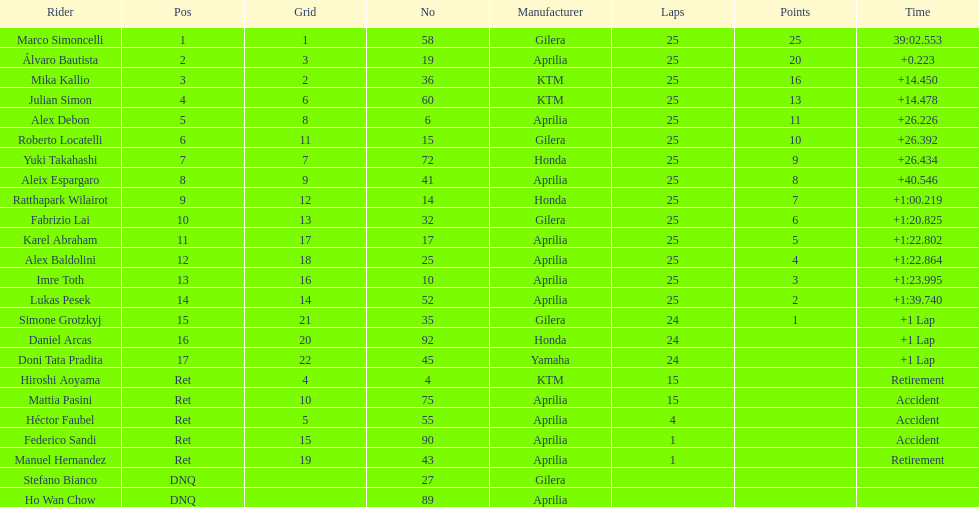Parse the table in full. {'header': ['Rider', 'Pos', 'Grid', 'No', 'Manufacturer', 'Laps', 'Points', 'Time'], 'rows': [['Marco Simoncelli', '1', '1', '58', 'Gilera', '25', '25', '39:02.553'], ['Álvaro Bautista', '2', '3', '19', 'Aprilia', '25', '20', '+0.223'], ['Mika Kallio', '3', '2', '36', 'KTM', '25', '16', '+14.450'], ['Julian Simon', '4', '6', '60', 'KTM', '25', '13', '+14.478'], ['Alex Debon', '5', '8', '6', 'Aprilia', '25', '11', '+26.226'], ['Roberto Locatelli', '6', '11', '15', 'Gilera', '25', '10', '+26.392'], ['Yuki Takahashi', '7', '7', '72', 'Honda', '25', '9', '+26.434'], ['Aleix Espargaro', '8', '9', '41', 'Aprilia', '25', '8', '+40.546'], ['Ratthapark Wilairot', '9', '12', '14', 'Honda', '25', '7', '+1:00.219'], ['Fabrizio Lai', '10', '13', '32', 'Gilera', '25', '6', '+1:20.825'], ['Karel Abraham', '11', '17', '17', 'Aprilia', '25', '5', '+1:22.802'], ['Alex Baldolini', '12', '18', '25', 'Aprilia', '25', '4', '+1:22.864'], ['Imre Toth', '13', '16', '10', 'Aprilia', '25', '3', '+1:23.995'], ['Lukas Pesek', '14', '14', '52', 'Aprilia', '25', '2', '+1:39.740'], ['Simone Grotzkyj', '15', '21', '35', 'Gilera', '24', '1', '+1 Lap'], ['Daniel Arcas', '16', '20', '92', 'Honda', '24', '', '+1 Lap'], ['Doni Tata Pradita', '17', '22', '45', 'Yamaha', '24', '', '+1 Lap'], ['Hiroshi Aoyama', 'Ret', '4', '4', 'KTM', '15', '', 'Retirement'], ['Mattia Pasini', 'Ret', '10', '75', 'Aprilia', '15', '', 'Accident'], ['Héctor Faubel', 'Ret', '5', '55', 'Aprilia', '4', '', 'Accident'], ['Federico Sandi', 'Ret', '15', '90', 'Aprilia', '1', '', 'Accident'], ['Manuel Hernandez', 'Ret', '19', '43', 'Aprilia', '1', '', 'Retirement'], ['Stefano Bianco', 'DNQ', '', '27', 'Gilera', '', '', ''], ['Ho Wan Chow', 'DNQ', '', '89', 'Aprilia', '', '', '']]} The total amount of riders who did not qualify 2. 